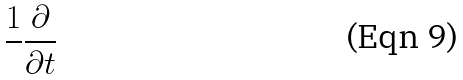<formula> <loc_0><loc_0><loc_500><loc_500>\frac { 1 } { } \frac { \partial } { \partial t }</formula> 